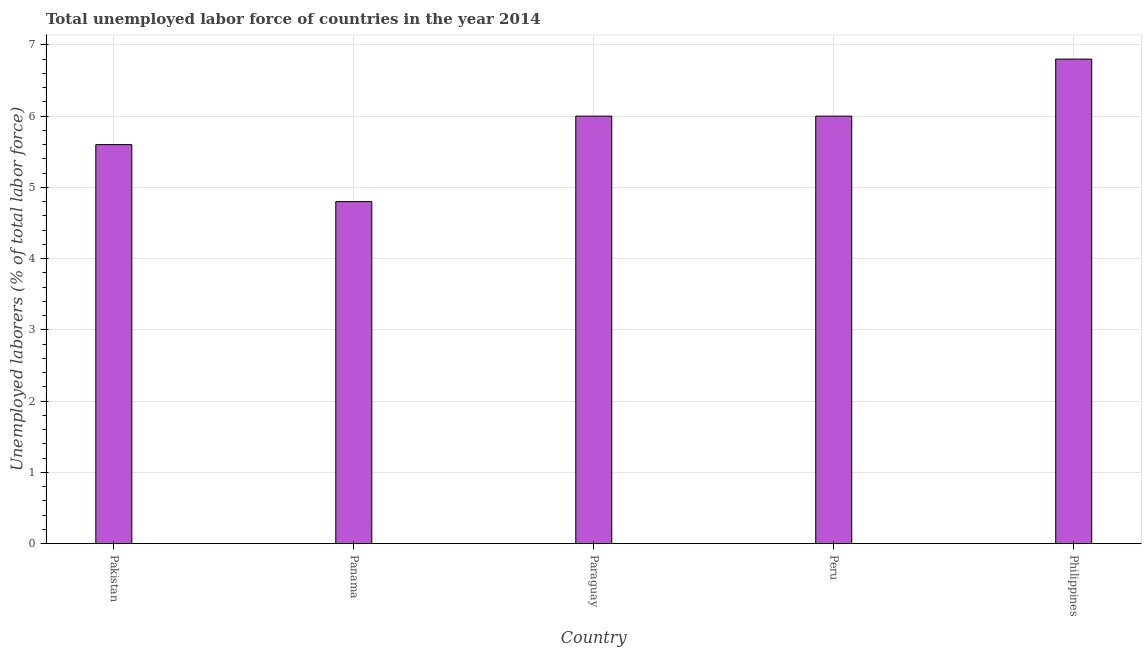What is the title of the graph?
Keep it short and to the point. Total unemployed labor force of countries in the year 2014. What is the label or title of the Y-axis?
Your answer should be compact. Unemployed laborers (% of total labor force). What is the total unemployed labour force in Philippines?
Your response must be concise. 6.8. Across all countries, what is the maximum total unemployed labour force?
Keep it short and to the point. 6.8. Across all countries, what is the minimum total unemployed labour force?
Your response must be concise. 4.8. In which country was the total unemployed labour force maximum?
Your response must be concise. Philippines. In which country was the total unemployed labour force minimum?
Keep it short and to the point. Panama. What is the sum of the total unemployed labour force?
Ensure brevity in your answer.  29.2. What is the difference between the total unemployed labour force in Paraguay and Peru?
Your answer should be very brief. 0. What is the average total unemployed labour force per country?
Provide a short and direct response. 5.84. What is the median total unemployed labour force?
Provide a short and direct response. 6. Is the total unemployed labour force in Pakistan less than that in Philippines?
Your answer should be compact. Yes. Is the sum of the total unemployed labour force in Panama and Paraguay greater than the maximum total unemployed labour force across all countries?
Your response must be concise. Yes. Are all the bars in the graph horizontal?
Make the answer very short. No. What is the Unemployed laborers (% of total labor force) of Pakistan?
Your response must be concise. 5.6. What is the Unemployed laborers (% of total labor force) of Panama?
Ensure brevity in your answer.  4.8. What is the Unemployed laborers (% of total labor force) in Philippines?
Your answer should be very brief. 6.8. What is the difference between the Unemployed laborers (% of total labor force) in Panama and Paraguay?
Make the answer very short. -1.2. What is the difference between the Unemployed laborers (% of total labor force) in Panama and Peru?
Keep it short and to the point. -1.2. What is the difference between the Unemployed laborers (% of total labor force) in Panama and Philippines?
Offer a very short reply. -2. What is the difference between the Unemployed laborers (% of total labor force) in Paraguay and Philippines?
Your answer should be compact. -0.8. What is the ratio of the Unemployed laborers (% of total labor force) in Pakistan to that in Panama?
Make the answer very short. 1.17. What is the ratio of the Unemployed laborers (% of total labor force) in Pakistan to that in Paraguay?
Keep it short and to the point. 0.93. What is the ratio of the Unemployed laborers (% of total labor force) in Pakistan to that in Peru?
Make the answer very short. 0.93. What is the ratio of the Unemployed laborers (% of total labor force) in Pakistan to that in Philippines?
Provide a succinct answer. 0.82. What is the ratio of the Unemployed laborers (% of total labor force) in Panama to that in Paraguay?
Your answer should be compact. 0.8. What is the ratio of the Unemployed laborers (% of total labor force) in Panama to that in Philippines?
Your answer should be very brief. 0.71. What is the ratio of the Unemployed laborers (% of total labor force) in Paraguay to that in Peru?
Provide a succinct answer. 1. What is the ratio of the Unemployed laborers (% of total labor force) in Paraguay to that in Philippines?
Make the answer very short. 0.88. What is the ratio of the Unemployed laborers (% of total labor force) in Peru to that in Philippines?
Your answer should be very brief. 0.88. 